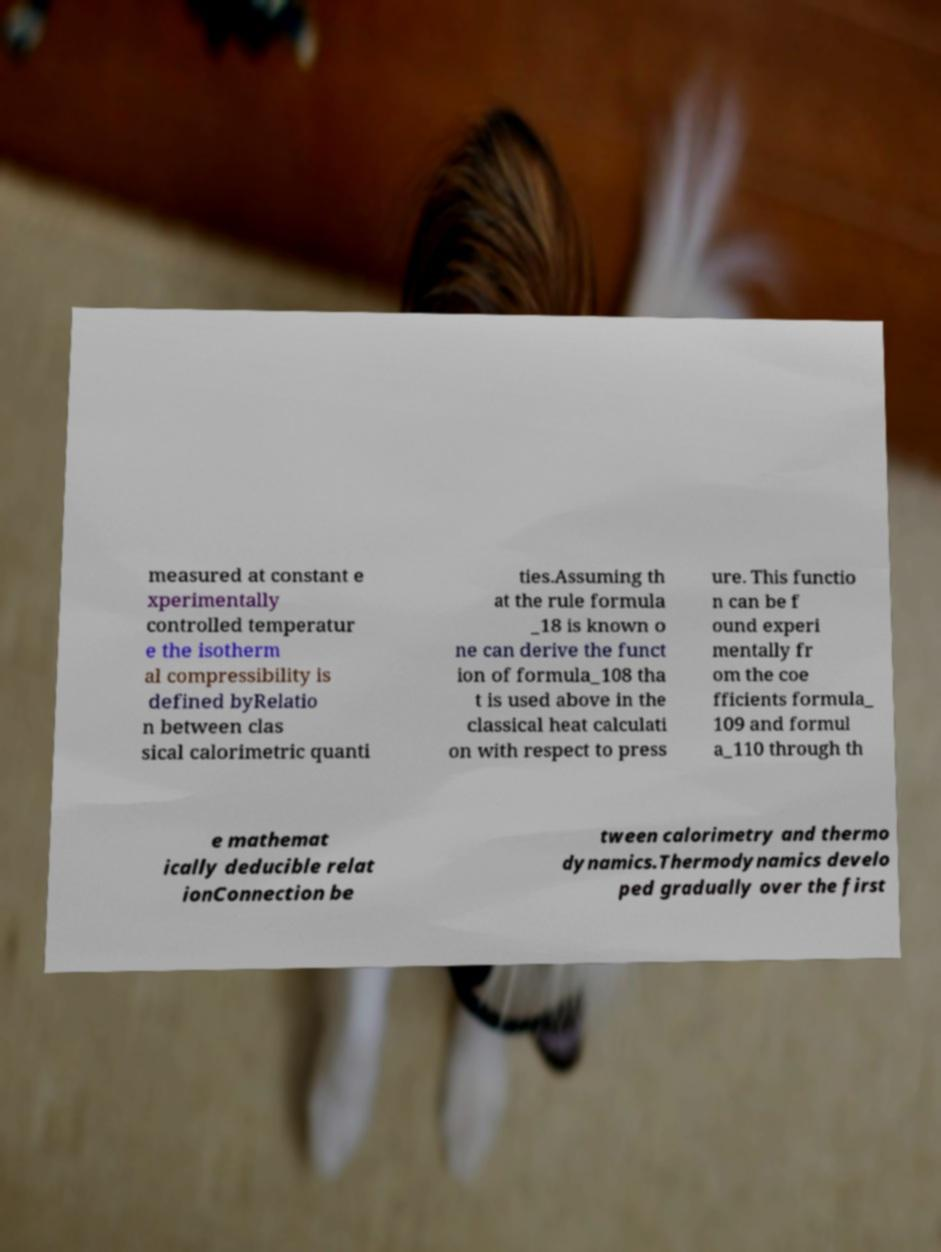I need the written content from this picture converted into text. Can you do that? measured at constant e xperimentally controlled temperatur e the isotherm al compressibility is defined byRelatio n between clas sical calorimetric quanti ties.Assuming th at the rule formula _18 is known o ne can derive the funct ion of formula_108 tha t is used above in the classical heat calculati on with respect to press ure. This functio n can be f ound experi mentally fr om the coe fficients formula_ 109 and formul a_110 through th e mathemat ically deducible relat ionConnection be tween calorimetry and thermo dynamics.Thermodynamics develo ped gradually over the first 